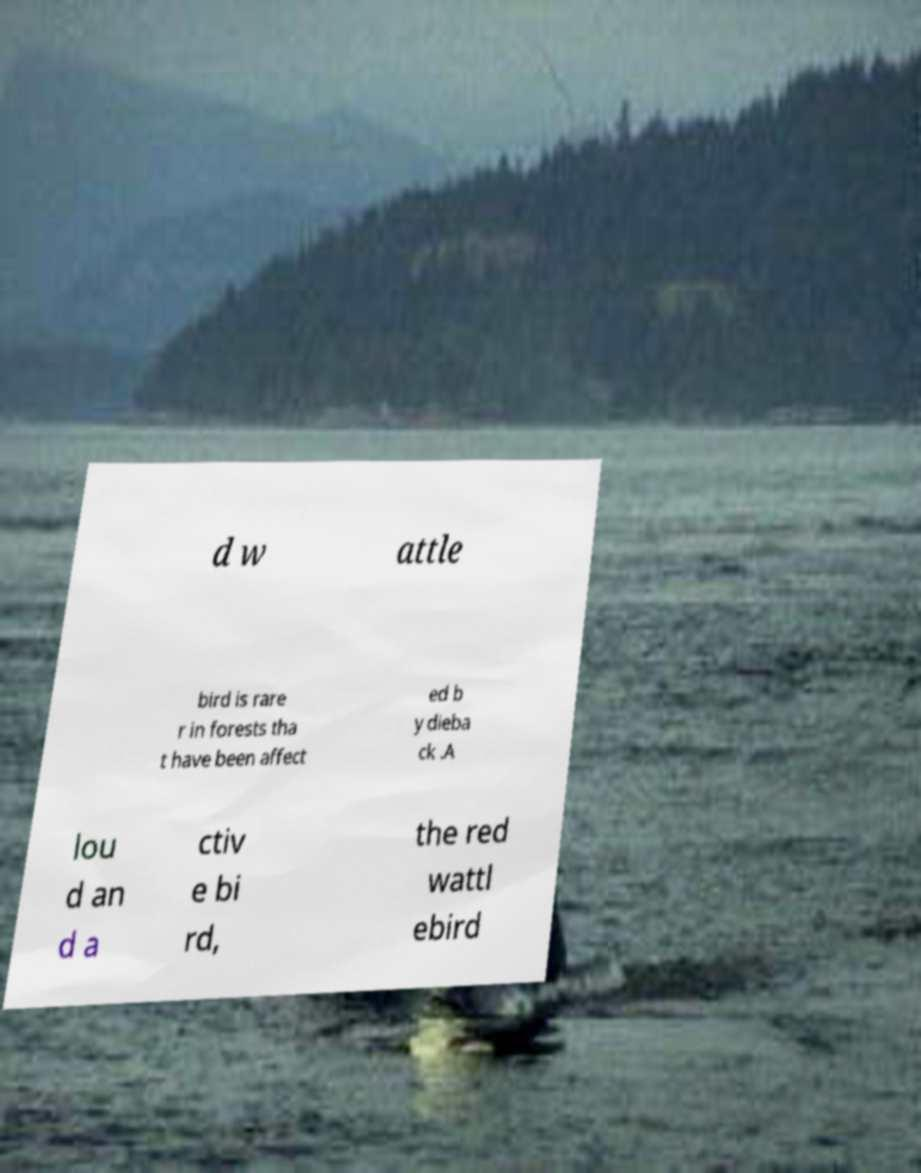I need the written content from this picture converted into text. Can you do that? d w attle bird is rare r in forests tha t have been affect ed b y dieba ck .A lou d an d a ctiv e bi rd, the red wattl ebird 